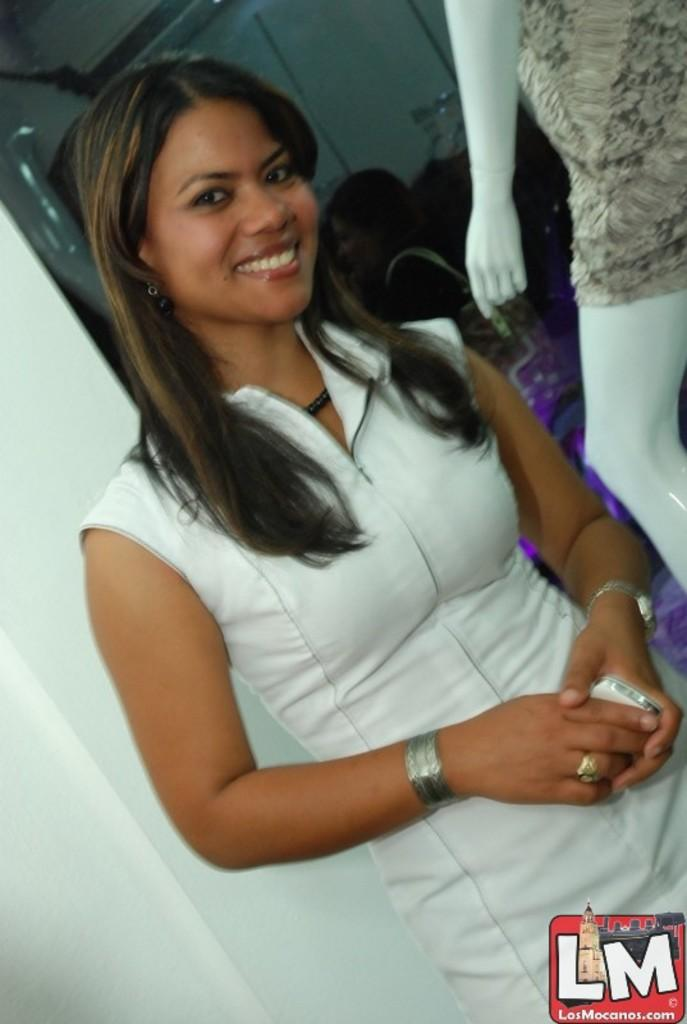Who is the main subject in the image? There is a girl in the center of the image. What can be seen in the background of the image? There are other people and a statue in the background of the image. What type of horn can be seen in the image? There is no horn present in the image. 